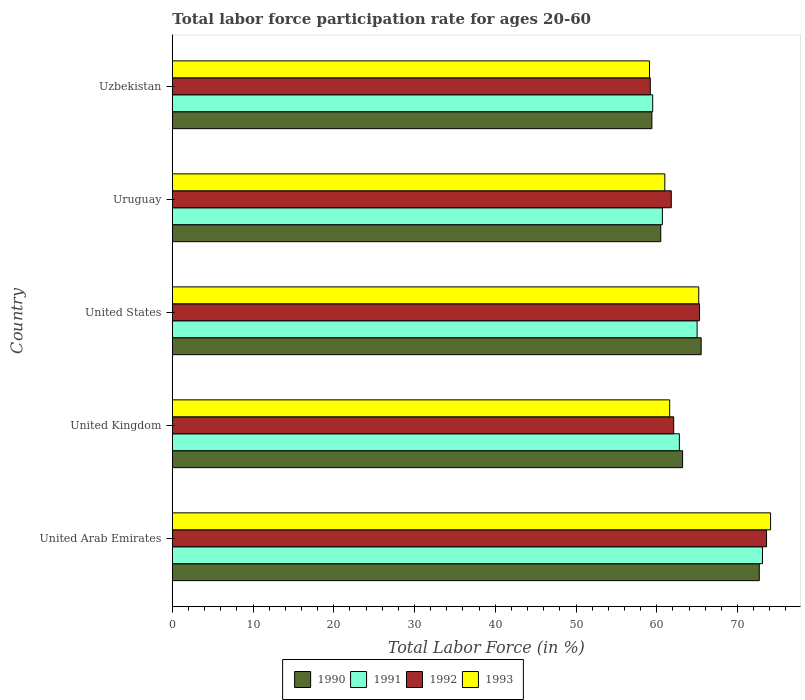Are the number of bars on each tick of the Y-axis equal?
Offer a terse response. Yes. How many bars are there on the 3rd tick from the bottom?
Offer a terse response. 4. What is the labor force participation rate in 1990 in United States?
Make the answer very short. 65.5. Across all countries, what is the maximum labor force participation rate in 1990?
Provide a short and direct response. 72.7. Across all countries, what is the minimum labor force participation rate in 1990?
Your answer should be compact. 59.4. In which country was the labor force participation rate in 1990 maximum?
Offer a terse response. United Arab Emirates. In which country was the labor force participation rate in 1991 minimum?
Ensure brevity in your answer.  Uzbekistan. What is the total labor force participation rate in 1990 in the graph?
Offer a terse response. 321.3. What is the difference between the labor force participation rate in 1991 in United Kingdom and that in United States?
Your response must be concise. -2.2. What is the difference between the labor force participation rate in 1991 in United Kingdom and the labor force participation rate in 1990 in United Arab Emirates?
Keep it short and to the point. -9.9. What is the average labor force participation rate in 1993 per country?
Keep it short and to the point. 64.2. What is the difference between the labor force participation rate in 1991 and labor force participation rate in 1990 in United Arab Emirates?
Your response must be concise. 0.4. What is the ratio of the labor force participation rate in 1993 in United Arab Emirates to that in United States?
Ensure brevity in your answer.  1.14. What is the difference between the highest and the second highest labor force participation rate in 1993?
Offer a very short reply. 8.9. What is the difference between the highest and the lowest labor force participation rate in 1992?
Offer a terse response. 14.4. In how many countries, is the labor force participation rate in 1991 greater than the average labor force participation rate in 1991 taken over all countries?
Provide a short and direct response. 2. Is the sum of the labor force participation rate in 1991 in United States and Uruguay greater than the maximum labor force participation rate in 1993 across all countries?
Give a very brief answer. Yes. How many countries are there in the graph?
Your answer should be very brief. 5. Does the graph contain grids?
Make the answer very short. No. What is the title of the graph?
Make the answer very short. Total labor force participation rate for ages 20-60. Does "1999" appear as one of the legend labels in the graph?
Offer a very short reply. No. What is the label or title of the X-axis?
Give a very brief answer. Total Labor Force (in %). What is the Total Labor Force (in %) of 1990 in United Arab Emirates?
Offer a very short reply. 72.7. What is the Total Labor Force (in %) of 1991 in United Arab Emirates?
Give a very brief answer. 73.1. What is the Total Labor Force (in %) in 1992 in United Arab Emirates?
Offer a very short reply. 73.6. What is the Total Labor Force (in %) in 1993 in United Arab Emirates?
Offer a very short reply. 74.1. What is the Total Labor Force (in %) in 1990 in United Kingdom?
Offer a terse response. 63.2. What is the Total Labor Force (in %) of 1991 in United Kingdom?
Your answer should be very brief. 62.8. What is the Total Labor Force (in %) in 1992 in United Kingdom?
Your answer should be compact. 62.1. What is the Total Labor Force (in %) in 1993 in United Kingdom?
Your answer should be compact. 61.6. What is the Total Labor Force (in %) in 1990 in United States?
Your response must be concise. 65.5. What is the Total Labor Force (in %) of 1992 in United States?
Your answer should be very brief. 65.3. What is the Total Labor Force (in %) of 1993 in United States?
Offer a very short reply. 65.2. What is the Total Labor Force (in %) in 1990 in Uruguay?
Your answer should be compact. 60.5. What is the Total Labor Force (in %) in 1991 in Uruguay?
Your answer should be very brief. 60.7. What is the Total Labor Force (in %) of 1992 in Uruguay?
Make the answer very short. 61.8. What is the Total Labor Force (in %) of 1993 in Uruguay?
Make the answer very short. 61. What is the Total Labor Force (in %) in 1990 in Uzbekistan?
Your answer should be very brief. 59.4. What is the Total Labor Force (in %) in 1991 in Uzbekistan?
Your answer should be compact. 59.5. What is the Total Labor Force (in %) of 1992 in Uzbekistan?
Your response must be concise. 59.2. What is the Total Labor Force (in %) of 1993 in Uzbekistan?
Make the answer very short. 59.1. Across all countries, what is the maximum Total Labor Force (in %) of 1990?
Provide a succinct answer. 72.7. Across all countries, what is the maximum Total Labor Force (in %) in 1991?
Provide a succinct answer. 73.1. Across all countries, what is the maximum Total Labor Force (in %) in 1992?
Ensure brevity in your answer.  73.6. Across all countries, what is the maximum Total Labor Force (in %) in 1993?
Provide a short and direct response. 74.1. Across all countries, what is the minimum Total Labor Force (in %) of 1990?
Ensure brevity in your answer.  59.4. Across all countries, what is the minimum Total Labor Force (in %) of 1991?
Offer a very short reply. 59.5. Across all countries, what is the minimum Total Labor Force (in %) of 1992?
Provide a short and direct response. 59.2. Across all countries, what is the minimum Total Labor Force (in %) in 1993?
Provide a short and direct response. 59.1. What is the total Total Labor Force (in %) of 1990 in the graph?
Your answer should be very brief. 321.3. What is the total Total Labor Force (in %) of 1991 in the graph?
Your response must be concise. 321.1. What is the total Total Labor Force (in %) of 1992 in the graph?
Give a very brief answer. 322. What is the total Total Labor Force (in %) in 1993 in the graph?
Give a very brief answer. 321. What is the difference between the Total Labor Force (in %) in 1991 in United Arab Emirates and that in United Kingdom?
Offer a terse response. 10.3. What is the difference between the Total Labor Force (in %) in 1992 in United Arab Emirates and that in United Kingdom?
Make the answer very short. 11.5. What is the difference between the Total Labor Force (in %) in 1993 in United Arab Emirates and that in United Kingdom?
Keep it short and to the point. 12.5. What is the difference between the Total Labor Force (in %) of 1991 in United Arab Emirates and that in Uruguay?
Offer a terse response. 12.4. What is the difference between the Total Labor Force (in %) in 1992 in United Arab Emirates and that in Uruguay?
Your response must be concise. 11.8. What is the difference between the Total Labor Force (in %) of 1990 in United Arab Emirates and that in Uzbekistan?
Provide a succinct answer. 13.3. What is the difference between the Total Labor Force (in %) in 1991 in United Arab Emirates and that in Uzbekistan?
Give a very brief answer. 13.6. What is the difference between the Total Labor Force (in %) of 1993 in United Arab Emirates and that in Uzbekistan?
Provide a succinct answer. 15. What is the difference between the Total Labor Force (in %) of 1990 in United Kingdom and that in United States?
Make the answer very short. -2.3. What is the difference between the Total Labor Force (in %) in 1993 in United Kingdom and that in United States?
Provide a short and direct response. -3.6. What is the difference between the Total Labor Force (in %) in 1993 in United Kingdom and that in Uruguay?
Give a very brief answer. 0.6. What is the difference between the Total Labor Force (in %) in 1990 in United Kingdom and that in Uzbekistan?
Your answer should be very brief. 3.8. What is the difference between the Total Labor Force (in %) in 1991 in United Kingdom and that in Uzbekistan?
Your answer should be compact. 3.3. What is the difference between the Total Labor Force (in %) in 1992 in United Kingdom and that in Uzbekistan?
Offer a very short reply. 2.9. What is the difference between the Total Labor Force (in %) in 1990 in United States and that in Uruguay?
Make the answer very short. 5. What is the difference between the Total Labor Force (in %) in 1991 in United States and that in Uruguay?
Give a very brief answer. 4.3. What is the difference between the Total Labor Force (in %) in 1993 in United States and that in Uruguay?
Give a very brief answer. 4.2. What is the difference between the Total Labor Force (in %) of 1991 in United States and that in Uzbekistan?
Keep it short and to the point. 5.5. What is the difference between the Total Labor Force (in %) of 1991 in Uruguay and that in Uzbekistan?
Your answer should be compact. 1.2. What is the difference between the Total Labor Force (in %) in 1992 in Uruguay and that in Uzbekistan?
Keep it short and to the point. 2.6. What is the difference between the Total Labor Force (in %) in 1993 in Uruguay and that in Uzbekistan?
Provide a short and direct response. 1.9. What is the difference between the Total Labor Force (in %) in 1990 in United Arab Emirates and the Total Labor Force (in %) in 1991 in United Kingdom?
Provide a succinct answer. 9.9. What is the difference between the Total Labor Force (in %) of 1990 in United Arab Emirates and the Total Labor Force (in %) of 1993 in United Kingdom?
Your answer should be very brief. 11.1. What is the difference between the Total Labor Force (in %) in 1990 in United Arab Emirates and the Total Labor Force (in %) in 1991 in United States?
Provide a short and direct response. 7.7. What is the difference between the Total Labor Force (in %) of 1990 in United Arab Emirates and the Total Labor Force (in %) of 1993 in United States?
Offer a very short reply. 7.5. What is the difference between the Total Labor Force (in %) of 1991 in United Arab Emirates and the Total Labor Force (in %) of 1992 in United States?
Provide a succinct answer. 7.8. What is the difference between the Total Labor Force (in %) in 1990 in United Arab Emirates and the Total Labor Force (in %) in 1991 in Uruguay?
Provide a succinct answer. 12. What is the difference between the Total Labor Force (in %) of 1990 in United Arab Emirates and the Total Labor Force (in %) of 1992 in Uruguay?
Give a very brief answer. 10.9. What is the difference between the Total Labor Force (in %) of 1990 in United Arab Emirates and the Total Labor Force (in %) of 1993 in Uruguay?
Provide a short and direct response. 11.7. What is the difference between the Total Labor Force (in %) of 1990 in United Arab Emirates and the Total Labor Force (in %) of 1991 in Uzbekistan?
Provide a short and direct response. 13.2. What is the difference between the Total Labor Force (in %) in 1991 in United Arab Emirates and the Total Labor Force (in %) in 1993 in Uzbekistan?
Give a very brief answer. 14. What is the difference between the Total Labor Force (in %) of 1990 in United Kingdom and the Total Labor Force (in %) of 1992 in United States?
Your answer should be very brief. -2.1. What is the difference between the Total Labor Force (in %) in 1991 in United Kingdom and the Total Labor Force (in %) in 1992 in United States?
Keep it short and to the point. -2.5. What is the difference between the Total Labor Force (in %) in 1991 in United Kingdom and the Total Labor Force (in %) in 1993 in United States?
Make the answer very short. -2.4. What is the difference between the Total Labor Force (in %) of 1991 in United Kingdom and the Total Labor Force (in %) of 1992 in Uruguay?
Offer a terse response. 1. What is the difference between the Total Labor Force (in %) of 1991 in United Kingdom and the Total Labor Force (in %) of 1993 in Uruguay?
Provide a short and direct response. 1.8. What is the difference between the Total Labor Force (in %) in 1990 in United Kingdom and the Total Labor Force (in %) in 1991 in Uzbekistan?
Offer a terse response. 3.7. What is the difference between the Total Labor Force (in %) of 1990 in United Kingdom and the Total Labor Force (in %) of 1993 in Uzbekistan?
Provide a succinct answer. 4.1. What is the difference between the Total Labor Force (in %) of 1991 in United Kingdom and the Total Labor Force (in %) of 1992 in Uzbekistan?
Offer a very short reply. 3.6. What is the difference between the Total Labor Force (in %) of 1991 in United Kingdom and the Total Labor Force (in %) of 1993 in Uzbekistan?
Give a very brief answer. 3.7. What is the difference between the Total Labor Force (in %) in 1992 in United Kingdom and the Total Labor Force (in %) in 1993 in Uzbekistan?
Give a very brief answer. 3. What is the difference between the Total Labor Force (in %) of 1990 in United States and the Total Labor Force (in %) of 1991 in Uruguay?
Ensure brevity in your answer.  4.8. What is the difference between the Total Labor Force (in %) of 1990 in United States and the Total Labor Force (in %) of 1992 in Uruguay?
Provide a short and direct response. 3.7. What is the difference between the Total Labor Force (in %) of 1990 in United States and the Total Labor Force (in %) of 1993 in Uruguay?
Your answer should be compact. 4.5. What is the difference between the Total Labor Force (in %) in 1991 in United States and the Total Labor Force (in %) in 1992 in Uruguay?
Give a very brief answer. 3.2. What is the difference between the Total Labor Force (in %) in 1990 in United States and the Total Labor Force (in %) in 1991 in Uzbekistan?
Keep it short and to the point. 6. What is the difference between the Total Labor Force (in %) of 1990 in United States and the Total Labor Force (in %) of 1992 in Uzbekistan?
Make the answer very short. 6.3. What is the difference between the Total Labor Force (in %) of 1990 in United States and the Total Labor Force (in %) of 1993 in Uzbekistan?
Provide a succinct answer. 6.4. What is the difference between the Total Labor Force (in %) in 1991 in United States and the Total Labor Force (in %) in 1992 in Uzbekistan?
Give a very brief answer. 5.8. What is the difference between the Total Labor Force (in %) of 1990 in Uruguay and the Total Labor Force (in %) of 1992 in Uzbekistan?
Make the answer very short. 1.3. What is the difference between the Total Labor Force (in %) in 1990 in Uruguay and the Total Labor Force (in %) in 1993 in Uzbekistan?
Your answer should be compact. 1.4. What is the difference between the Total Labor Force (in %) of 1992 in Uruguay and the Total Labor Force (in %) of 1993 in Uzbekistan?
Provide a short and direct response. 2.7. What is the average Total Labor Force (in %) of 1990 per country?
Keep it short and to the point. 64.26. What is the average Total Labor Force (in %) of 1991 per country?
Offer a terse response. 64.22. What is the average Total Labor Force (in %) of 1992 per country?
Your answer should be very brief. 64.4. What is the average Total Labor Force (in %) of 1993 per country?
Your response must be concise. 64.2. What is the difference between the Total Labor Force (in %) in 1990 and Total Labor Force (in %) in 1991 in United Arab Emirates?
Offer a terse response. -0.4. What is the difference between the Total Labor Force (in %) in 1990 and Total Labor Force (in %) in 1992 in United Arab Emirates?
Your response must be concise. -0.9. What is the difference between the Total Labor Force (in %) in 1990 and Total Labor Force (in %) in 1993 in United Arab Emirates?
Ensure brevity in your answer.  -1.4. What is the difference between the Total Labor Force (in %) of 1991 and Total Labor Force (in %) of 1993 in United Arab Emirates?
Your response must be concise. -1. What is the difference between the Total Labor Force (in %) of 1992 and Total Labor Force (in %) of 1993 in United Arab Emirates?
Make the answer very short. -0.5. What is the difference between the Total Labor Force (in %) of 1990 and Total Labor Force (in %) of 1992 in United Kingdom?
Make the answer very short. 1.1. What is the difference between the Total Labor Force (in %) in 1991 and Total Labor Force (in %) in 1992 in United Kingdom?
Provide a succinct answer. 0.7. What is the difference between the Total Labor Force (in %) in 1991 and Total Labor Force (in %) in 1993 in United Kingdom?
Your answer should be compact. 1.2. What is the difference between the Total Labor Force (in %) of 1990 and Total Labor Force (in %) of 1992 in United States?
Your answer should be compact. 0.2. What is the difference between the Total Labor Force (in %) of 1990 and Total Labor Force (in %) of 1993 in United States?
Ensure brevity in your answer.  0.3. What is the difference between the Total Labor Force (in %) of 1991 and Total Labor Force (in %) of 1992 in United States?
Ensure brevity in your answer.  -0.3. What is the difference between the Total Labor Force (in %) of 1992 and Total Labor Force (in %) of 1993 in United States?
Provide a short and direct response. 0.1. What is the difference between the Total Labor Force (in %) of 1990 and Total Labor Force (in %) of 1991 in Uruguay?
Provide a succinct answer. -0.2. What is the difference between the Total Labor Force (in %) of 1991 and Total Labor Force (in %) of 1993 in Uruguay?
Give a very brief answer. -0.3. What is the difference between the Total Labor Force (in %) of 1990 and Total Labor Force (in %) of 1991 in Uzbekistan?
Offer a terse response. -0.1. What is the difference between the Total Labor Force (in %) in 1990 and Total Labor Force (in %) in 1992 in Uzbekistan?
Make the answer very short. 0.2. What is the difference between the Total Labor Force (in %) of 1990 and Total Labor Force (in %) of 1993 in Uzbekistan?
Ensure brevity in your answer.  0.3. What is the difference between the Total Labor Force (in %) in 1991 and Total Labor Force (in %) in 1993 in Uzbekistan?
Offer a very short reply. 0.4. What is the difference between the Total Labor Force (in %) of 1992 and Total Labor Force (in %) of 1993 in Uzbekistan?
Give a very brief answer. 0.1. What is the ratio of the Total Labor Force (in %) in 1990 in United Arab Emirates to that in United Kingdom?
Keep it short and to the point. 1.15. What is the ratio of the Total Labor Force (in %) of 1991 in United Arab Emirates to that in United Kingdom?
Keep it short and to the point. 1.16. What is the ratio of the Total Labor Force (in %) of 1992 in United Arab Emirates to that in United Kingdom?
Make the answer very short. 1.19. What is the ratio of the Total Labor Force (in %) in 1993 in United Arab Emirates to that in United Kingdom?
Your answer should be very brief. 1.2. What is the ratio of the Total Labor Force (in %) in 1990 in United Arab Emirates to that in United States?
Offer a very short reply. 1.11. What is the ratio of the Total Labor Force (in %) of 1991 in United Arab Emirates to that in United States?
Your answer should be very brief. 1.12. What is the ratio of the Total Labor Force (in %) in 1992 in United Arab Emirates to that in United States?
Provide a succinct answer. 1.13. What is the ratio of the Total Labor Force (in %) of 1993 in United Arab Emirates to that in United States?
Your response must be concise. 1.14. What is the ratio of the Total Labor Force (in %) of 1990 in United Arab Emirates to that in Uruguay?
Ensure brevity in your answer.  1.2. What is the ratio of the Total Labor Force (in %) in 1991 in United Arab Emirates to that in Uruguay?
Offer a very short reply. 1.2. What is the ratio of the Total Labor Force (in %) of 1992 in United Arab Emirates to that in Uruguay?
Make the answer very short. 1.19. What is the ratio of the Total Labor Force (in %) in 1993 in United Arab Emirates to that in Uruguay?
Keep it short and to the point. 1.21. What is the ratio of the Total Labor Force (in %) of 1990 in United Arab Emirates to that in Uzbekistan?
Make the answer very short. 1.22. What is the ratio of the Total Labor Force (in %) of 1991 in United Arab Emirates to that in Uzbekistan?
Your answer should be compact. 1.23. What is the ratio of the Total Labor Force (in %) in 1992 in United Arab Emirates to that in Uzbekistan?
Your response must be concise. 1.24. What is the ratio of the Total Labor Force (in %) in 1993 in United Arab Emirates to that in Uzbekistan?
Your response must be concise. 1.25. What is the ratio of the Total Labor Force (in %) of 1990 in United Kingdom to that in United States?
Offer a very short reply. 0.96. What is the ratio of the Total Labor Force (in %) in 1991 in United Kingdom to that in United States?
Provide a succinct answer. 0.97. What is the ratio of the Total Labor Force (in %) in 1992 in United Kingdom to that in United States?
Your response must be concise. 0.95. What is the ratio of the Total Labor Force (in %) of 1993 in United Kingdom to that in United States?
Ensure brevity in your answer.  0.94. What is the ratio of the Total Labor Force (in %) in 1990 in United Kingdom to that in Uruguay?
Ensure brevity in your answer.  1.04. What is the ratio of the Total Labor Force (in %) in 1991 in United Kingdom to that in Uruguay?
Ensure brevity in your answer.  1.03. What is the ratio of the Total Labor Force (in %) of 1992 in United Kingdom to that in Uruguay?
Your response must be concise. 1. What is the ratio of the Total Labor Force (in %) of 1993 in United Kingdom to that in Uruguay?
Offer a terse response. 1.01. What is the ratio of the Total Labor Force (in %) of 1990 in United Kingdom to that in Uzbekistan?
Offer a terse response. 1.06. What is the ratio of the Total Labor Force (in %) of 1991 in United Kingdom to that in Uzbekistan?
Provide a short and direct response. 1.06. What is the ratio of the Total Labor Force (in %) of 1992 in United Kingdom to that in Uzbekistan?
Give a very brief answer. 1.05. What is the ratio of the Total Labor Force (in %) in 1993 in United Kingdom to that in Uzbekistan?
Provide a short and direct response. 1.04. What is the ratio of the Total Labor Force (in %) of 1990 in United States to that in Uruguay?
Offer a very short reply. 1.08. What is the ratio of the Total Labor Force (in %) in 1991 in United States to that in Uruguay?
Your answer should be compact. 1.07. What is the ratio of the Total Labor Force (in %) of 1992 in United States to that in Uruguay?
Offer a very short reply. 1.06. What is the ratio of the Total Labor Force (in %) of 1993 in United States to that in Uruguay?
Offer a terse response. 1.07. What is the ratio of the Total Labor Force (in %) of 1990 in United States to that in Uzbekistan?
Make the answer very short. 1.1. What is the ratio of the Total Labor Force (in %) of 1991 in United States to that in Uzbekistan?
Make the answer very short. 1.09. What is the ratio of the Total Labor Force (in %) of 1992 in United States to that in Uzbekistan?
Provide a succinct answer. 1.1. What is the ratio of the Total Labor Force (in %) of 1993 in United States to that in Uzbekistan?
Your answer should be compact. 1.1. What is the ratio of the Total Labor Force (in %) of 1990 in Uruguay to that in Uzbekistan?
Your answer should be very brief. 1.02. What is the ratio of the Total Labor Force (in %) of 1991 in Uruguay to that in Uzbekistan?
Your answer should be compact. 1.02. What is the ratio of the Total Labor Force (in %) of 1992 in Uruguay to that in Uzbekistan?
Give a very brief answer. 1.04. What is the ratio of the Total Labor Force (in %) of 1993 in Uruguay to that in Uzbekistan?
Make the answer very short. 1.03. What is the difference between the highest and the second highest Total Labor Force (in %) of 1990?
Offer a very short reply. 7.2. What is the difference between the highest and the second highest Total Labor Force (in %) of 1991?
Provide a short and direct response. 8.1. What is the difference between the highest and the second highest Total Labor Force (in %) in 1992?
Provide a short and direct response. 8.3. What is the difference between the highest and the lowest Total Labor Force (in %) in 1991?
Keep it short and to the point. 13.6. What is the difference between the highest and the lowest Total Labor Force (in %) in 1992?
Ensure brevity in your answer.  14.4. 